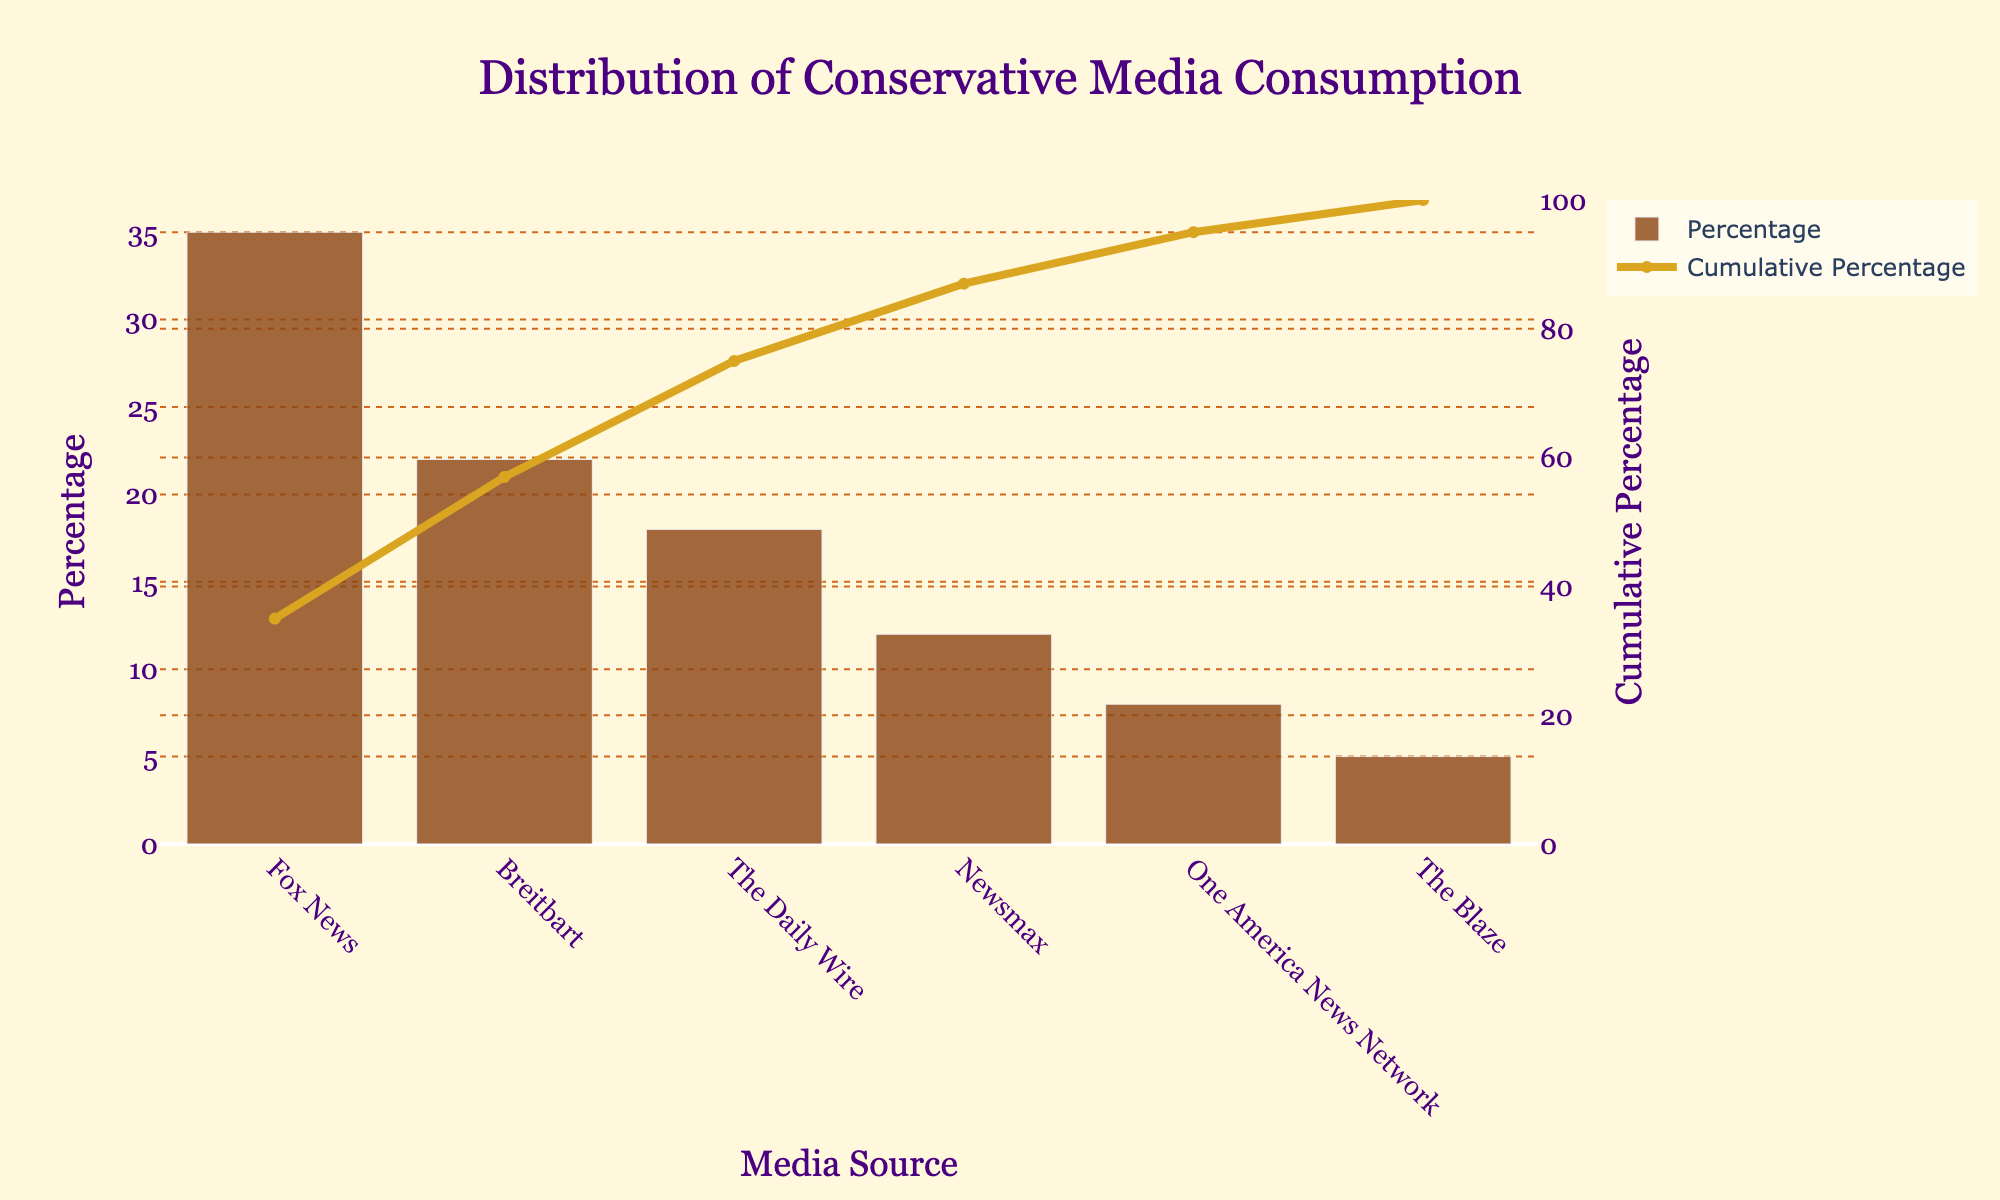What is the title of the figure? The title of the figure is displayed at the top of the chart. It provides an overview of what the chart will be about. In this case, the title reads "Distribution of Conservative Media Consumption".
Answer: Distribution of Conservative Media Consumption Which media source has the highest percentage of consumption? To find the media source with the highest percentage, look for the tallest bar in the bar chart. The tallest bar corresponds to Fox News with 35%.
Answer: Fox News What percentage of conservative media consumption is attributed to Newsmax? Locate the bar labeled "Newsmax" and check its height relative to the y-axis. The corresponding percentage is 12%.
Answer: 12% What color is the bar representing Breitbart in the chart? Each media source in the chart is represented by a bar of a specific color. Breitbart is represented by a brownish bar.
Answer: Brown What is the cumulative percentage after including The Daily Wire? The cumulative percentage is labeled on the line plot and represents the sum of percentages up to The Daily Wire. Calculate 35% (Fox News) + 22% (Breitbart) + 18% (The Daily Wire) = 75%.
Answer: 75% How many media sources are displayed in the chart? Count the number of distinct bars in the chart. Each bar represents a different media source. There are six bars in total.
Answer: 6 How does the percentage of Newsmax compare to that of One America News Network (OANN)? Compare the height of the bars for Newsmax and OANN. Newsmax is at 12%, while OANN is at 8%. Newsmax has a higher percentage than OANN.
Answer: Newsmax has a higher percentage Which media sources together constitute more than half of the conservative media consumption? Add the percentages of the media sources starting from the highest. Fox News (35%) + Breitbart (22%) together make up 57%, surpassing half (50%).
Answer: Fox News and Breitbart What is the cumulative percentage for The Blaze? Locate The Blaze on the x-axis and trace the line plot to the corresponding value on the secondary y-axis on the right. Sum the percentages of Fox News (35%), Breitbart (22%), The Daily Wire (18%), Newsmax (12%), and One America News Network (8%) first, which equals: 35 + 22 + 18 + 12 + 8 = 95%. The cumulative percentage for The Blaze is 100%.
Answer: 100% What is the difference in the percentage of consumption between the highest and lowest media sources? Find the percentages of the highest and lowest media sources, which are Fox News (35%) and The Blaze (5%) respectively. Subtract the smallest percentage from the largest: 35 - 5 = 30.
Answer: 30% 